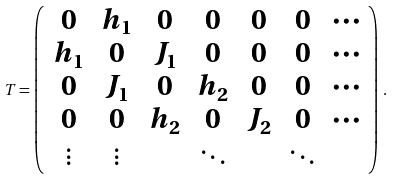Convert formula to latex. <formula><loc_0><loc_0><loc_500><loc_500>T = \left ( \begin{array} { c c c c c c c } 0 & h _ { 1 } & 0 & 0 & 0 & 0 & \cdots \\ h _ { 1 } & 0 & J _ { 1 } & 0 & 0 & 0 & \cdots \\ 0 & J _ { 1 } & 0 & h _ { 2 } & 0 & 0 & \cdots \\ 0 & 0 & h _ { 2 } & 0 & J _ { 2 } & 0 & \cdots \\ \vdots & \vdots & & \ddots & & \ddots & \end{array} \right ) \, .</formula> 